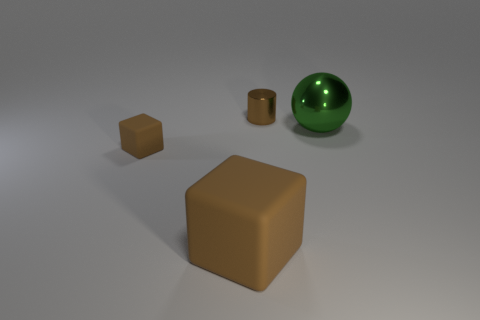Is there a green rubber object of the same shape as the large brown rubber object?
Your answer should be very brief. No. Does the small thing in front of the large green shiny object have the same material as the small object that is to the right of the large matte cube?
Make the answer very short. No. What size is the brown matte cube that is behind the cube that is on the right side of the small rubber thing to the left of the large brown matte cube?
Your answer should be compact. Small. There is a cube that is the same size as the green shiny thing; what is it made of?
Make the answer very short. Rubber. Is there a yellow block that has the same size as the green metallic sphere?
Ensure brevity in your answer.  No. Do the green metallic object and the big brown thing have the same shape?
Provide a succinct answer. No. There is a tiny thing that is on the left side of the brown thing that is on the right side of the big brown object; are there any small rubber things that are behind it?
Your answer should be very brief. No. What number of other things are there of the same color as the big rubber object?
Your response must be concise. 2. Does the shiny thing to the right of the small metal cylinder have the same size as the matte cube that is in front of the tiny brown rubber cube?
Your answer should be very brief. Yes. Are there the same number of rubber cubes that are in front of the big green thing and tiny brown matte objects that are left of the small brown cube?
Give a very brief answer. No. 